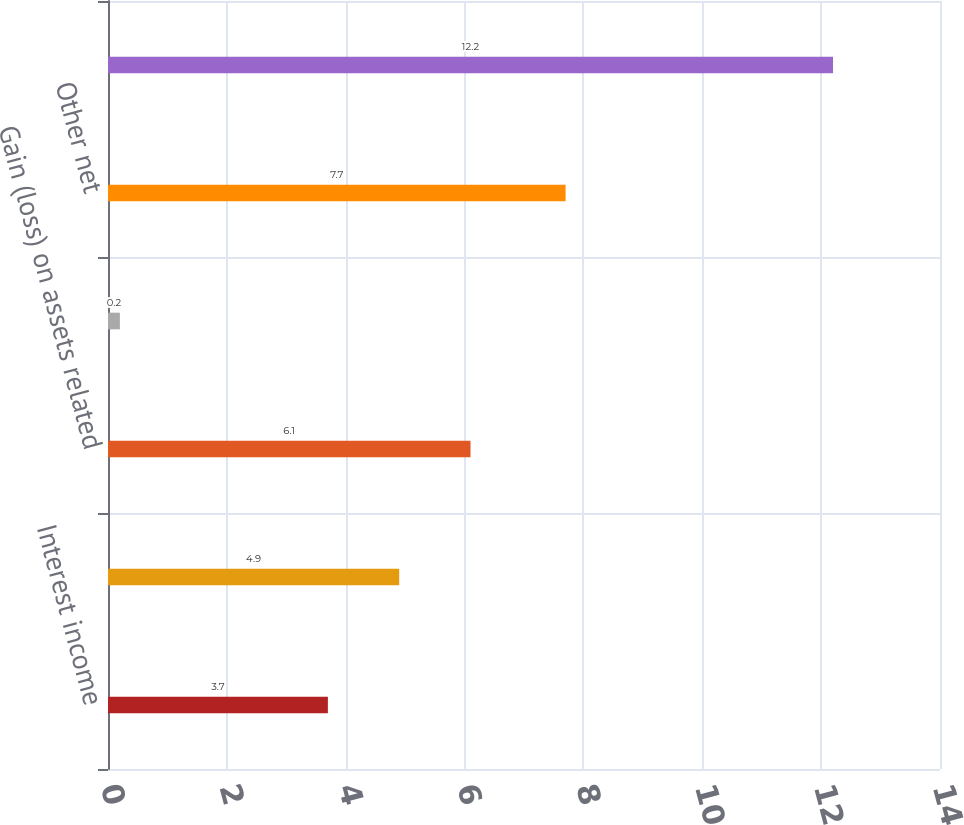Convert chart to OTSL. <chart><loc_0><loc_0><loc_500><loc_500><bar_chart><fcel>Interest income<fcel>Interest expense<fcel>Gain (loss) on assets related<fcel>Foreign currency exchange gain<fcel>Other net<fcel>Total<nl><fcel>3.7<fcel>4.9<fcel>6.1<fcel>0.2<fcel>7.7<fcel>12.2<nl></chart> 